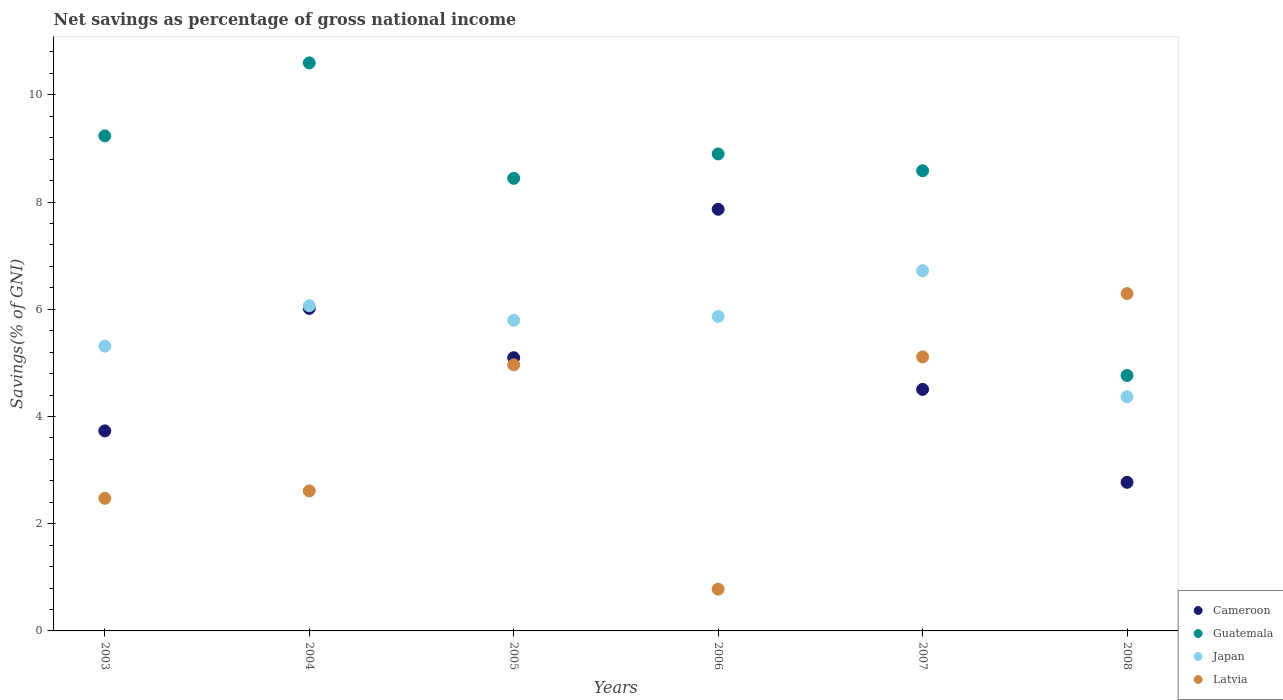What is the total savings in Japan in 2007?
Offer a terse response. 6.72. Across all years, what is the maximum total savings in Latvia?
Your answer should be very brief. 6.29. Across all years, what is the minimum total savings in Japan?
Make the answer very short. 4.37. In which year was the total savings in Latvia maximum?
Your answer should be compact. 2008. In which year was the total savings in Japan minimum?
Provide a succinct answer. 2008. What is the total total savings in Latvia in the graph?
Ensure brevity in your answer.  22.23. What is the difference between the total savings in Latvia in 2003 and that in 2006?
Provide a succinct answer. 1.69. What is the difference between the total savings in Cameroon in 2005 and the total savings in Japan in 2008?
Your response must be concise. 0.73. What is the average total savings in Latvia per year?
Your response must be concise. 3.71. In the year 2004, what is the difference between the total savings in Latvia and total savings in Cameroon?
Provide a succinct answer. -3.4. What is the ratio of the total savings in Japan in 2003 to that in 2008?
Your answer should be compact. 1.22. Is the total savings in Guatemala in 2003 less than that in 2007?
Give a very brief answer. No. Is the difference between the total savings in Latvia in 2003 and 2008 greater than the difference between the total savings in Cameroon in 2003 and 2008?
Offer a very short reply. No. What is the difference between the highest and the second highest total savings in Latvia?
Your answer should be compact. 1.18. What is the difference between the highest and the lowest total savings in Cameroon?
Give a very brief answer. 5.09. In how many years, is the total savings in Latvia greater than the average total savings in Latvia taken over all years?
Provide a succinct answer. 3. Is the sum of the total savings in Latvia in 2007 and 2008 greater than the maximum total savings in Japan across all years?
Your answer should be very brief. Yes. Is it the case that in every year, the sum of the total savings in Cameroon and total savings in Latvia  is greater than the sum of total savings in Guatemala and total savings in Japan?
Your answer should be very brief. No. Is it the case that in every year, the sum of the total savings in Guatemala and total savings in Cameroon  is greater than the total savings in Japan?
Your answer should be compact. Yes. Does the total savings in Japan monotonically increase over the years?
Give a very brief answer. No. Is the total savings in Latvia strictly greater than the total savings in Japan over the years?
Make the answer very short. No. Is the total savings in Guatemala strictly less than the total savings in Japan over the years?
Your answer should be very brief. No. Are the values on the major ticks of Y-axis written in scientific E-notation?
Offer a terse response. No. Does the graph contain any zero values?
Offer a terse response. No. Where does the legend appear in the graph?
Keep it short and to the point. Bottom right. What is the title of the graph?
Your answer should be very brief. Net savings as percentage of gross national income. Does "Togo" appear as one of the legend labels in the graph?
Your response must be concise. No. What is the label or title of the Y-axis?
Provide a short and direct response. Savings(% of GNI). What is the Savings(% of GNI) of Cameroon in 2003?
Provide a short and direct response. 3.73. What is the Savings(% of GNI) of Guatemala in 2003?
Provide a succinct answer. 9.24. What is the Savings(% of GNI) of Japan in 2003?
Offer a terse response. 5.31. What is the Savings(% of GNI) in Latvia in 2003?
Provide a short and direct response. 2.47. What is the Savings(% of GNI) of Cameroon in 2004?
Your answer should be very brief. 6.02. What is the Savings(% of GNI) of Guatemala in 2004?
Provide a succinct answer. 10.6. What is the Savings(% of GNI) in Japan in 2004?
Your answer should be very brief. 6.07. What is the Savings(% of GNI) of Latvia in 2004?
Ensure brevity in your answer.  2.61. What is the Savings(% of GNI) of Cameroon in 2005?
Ensure brevity in your answer.  5.1. What is the Savings(% of GNI) of Guatemala in 2005?
Provide a succinct answer. 8.44. What is the Savings(% of GNI) of Japan in 2005?
Make the answer very short. 5.79. What is the Savings(% of GNI) of Latvia in 2005?
Give a very brief answer. 4.96. What is the Savings(% of GNI) in Cameroon in 2006?
Offer a very short reply. 7.87. What is the Savings(% of GNI) in Guatemala in 2006?
Provide a short and direct response. 8.9. What is the Savings(% of GNI) of Japan in 2006?
Make the answer very short. 5.86. What is the Savings(% of GNI) in Latvia in 2006?
Provide a short and direct response. 0.78. What is the Savings(% of GNI) in Cameroon in 2007?
Offer a terse response. 4.51. What is the Savings(% of GNI) in Guatemala in 2007?
Give a very brief answer. 8.58. What is the Savings(% of GNI) in Japan in 2007?
Your answer should be compact. 6.72. What is the Savings(% of GNI) in Latvia in 2007?
Your answer should be very brief. 5.11. What is the Savings(% of GNI) in Cameroon in 2008?
Offer a terse response. 2.77. What is the Savings(% of GNI) in Guatemala in 2008?
Provide a short and direct response. 4.76. What is the Savings(% of GNI) in Japan in 2008?
Your answer should be compact. 4.37. What is the Savings(% of GNI) of Latvia in 2008?
Keep it short and to the point. 6.29. Across all years, what is the maximum Savings(% of GNI) of Cameroon?
Ensure brevity in your answer.  7.87. Across all years, what is the maximum Savings(% of GNI) of Guatemala?
Your answer should be compact. 10.6. Across all years, what is the maximum Savings(% of GNI) in Japan?
Make the answer very short. 6.72. Across all years, what is the maximum Savings(% of GNI) of Latvia?
Offer a very short reply. 6.29. Across all years, what is the minimum Savings(% of GNI) of Cameroon?
Provide a succinct answer. 2.77. Across all years, what is the minimum Savings(% of GNI) of Guatemala?
Keep it short and to the point. 4.76. Across all years, what is the minimum Savings(% of GNI) of Japan?
Offer a very short reply. 4.37. Across all years, what is the minimum Savings(% of GNI) of Latvia?
Your answer should be compact. 0.78. What is the total Savings(% of GNI) in Cameroon in the graph?
Provide a succinct answer. 29.99. What is the total Savings(% of GNI) of Guatemala in the graph?
Make the answer very short. 50.52. What is the total Savings(% of GNI) in Japan in the graph?
Provide a short and direct response. 34.12. What is the total Savings(% of GNI) in Latvia in the graph?
Your answer should be very brief. 22.23. What is the difference between the Savings(% of GNI) of Cameroon in 2003 and that in 2004?
Keep it short and to the point. -2.28. What is the difference between the Savings(% of GNI) in Guatemala in 2003 and that in 2004?
Keep it short and to the point. -1.36. What is the difference between the Savings(% of GNI) in Japan in 2003 and that in 2004?
Provide a short and direct response. -0.75. What is the difference between the Savings(% of GNI) of Latvia in 2003 and that in 2004?
Ensure brevity in your answer.  -0.14. What is the difference between the Savings(% of GNI) in Cameroon in 2003 and that in 2005?
Offer a terse response. -1.36. What is the difference between the Savings(% of GNI) in Guatemala in 2003 and that in 2005?
Your response must be concise. 0.79. What is the difference between the Savings(% of GNI) in Japan in 2003 and that in 2005?
Your answer should be very brief. -0.48. What is the difference between the Savings(% of GNI) of Latvia in 2003 and that in 2005?
Provide a succinct answer. -2.49. What is the difference between the Savings(% of GNI) in Cameroon in 2003 and that in 2006?
Offer a very short reply. -4.13. What is the difference between the Savings(% of GNI) in Guatemala in 2003 and that in 2006?
Make the answer very short. 0.34. What is the difference between the Savings(% of GNI) in Japan in 2003 and that in 2006?
Make the answer very short. -0.55. What is the difference between the Savings(% of GNI) of Latvia in 2003 and that in 2006?
Offer a terse response. 1.7. What is the difference between the Savings(% of GNI) of Cameroon in 2003 and that in 2007?
Provide a short and direct response. -0.77. What is the difference between the Savings(% of GNI) in Guatemala in 2003 and that in 2007?
Provide a short and direct response. 0.65. What is the difference between the Savings(% of GNI) in Japan in 2003 and that in 2007?
Your response must be concise. -1.41. What is the difference between the Savings(% of GNI) in Latvia in 2003 and that in 2007?
Make the answer very short. -2.64. What is the difference between the Savings(% of GNI) in Cameroon in 2003 and that in 2008?
Your answer should be compact. 0.96. What is the difference between the Savings(% of GNI) in Guatemala in 2003 and that in 2008?
Give a very brief answer. 4.47. What is the difference between the Savings(% of GNI) of Japan in 2003 and that in 2008?
Your answer should be very brief. 0.94. What is the difference between the Savings(% of GNI) of Latvia in 2003 and that in 2008?
Offer a terse response. -3.82. What is the difference between the Savings(% of GNI) of Cameroon in 2004 and that in 2005?
Offer a very short reply. 0.92. What is the difference between the Savings(% of GNI) in Guatemala in 2004 and that in 2005?
Your answer should be very brief. 2.15. What is the difference between the Savings(% of GNI) in Japan in 2004 and that in 2005?
Provide a short and direct response. 0.27. What is the difference between the Savings(% of GNI) of Latvia in 2004 and that in 2005?
Give a very brief answer. -2.35. What is the difference between the Savings(% of GNI) in Cameroon in 2004 and that in 2006?
Give a very brief answer. -1.85. What is the difference between the Savings(% of GNI) of Guatemala in 2004 and that in 2006?
Give a very brief answer. 1.7. What is the difference between the Savings(% of GNI) in Japan in 2004 and that in 2006?
Ensure brevity in your answer.  0.2. What is the difference between the Savings(% of GNI) of Latvia in 2004 and that in 2006?
Give a very brief answer. 1.83. What is the difference between the Savings(% of GNI) of Cameroon in 2004 and that in 2007?
Your answer should be very brief. 1.51. What is the difference between the Savings(% of GNI) of Guatemala in 2004 and that in 2007?
Your answer should be compact. 2.01. What is the difference between the Savings(% of GNI) of Japan in 2004 and that in 2007?
Offer a very short reply. -0.65. What is the difference between the Savings(% of GNI) in Latvia in 2004 and that in 2007?
Give a very brief answer. -2.5. What is the difference between the Savings(% of GNI) of Cameroon in 2004 and that in 2008?
Your answer should be compact. 3.24. What is the difference between the Savings(% of GNI) in Guatemala in 2004 and that in 2008?
Give a very brief answer. 5.83. What is the difference between the Savings(% of GNI) in Japan in 2004 and that in 2008?
Ensure brevity in your answer.  1.7. What is the difference between the Savings(% of GNI) in Latvia in 2004 and that in 2008?
Ensure brevity in your answer.  -3.68. What is the difference between the Savings(% of GNI) of Cameroon in 2005 and that in 2006?
Offer a very short reply. -2.77. What is the difference between the Savings(% of GNI) of Guatemala in 2005 and that in 2006?
Provide a succinct answer. -0.46. What is the difference between the Savings(% of GNI) in Japan in 2005 and that in 2006?
Your answer should be very brief. -0.07. What is the difference between the Savings(% of GNI) of Latvia in 2005 and that in 2006?
Your response must be concise. 4.19. What is the difference between the Savings(% of GNI) in Cameroon in 2005 and that in 2007?
Your response must be concise. 0.59. What is the difference between the Savings(% of GNI) of Guatemala in 2005 and that in 2007?
Offer a terse response. -0.14. What is the difference between the Savings(% of GNI) in Japan in 2005 and that in 2007?
Your answer should be compact. -0.93. What is the difference between the Savings(% of GNI) in Latvia in 2005 and that in 2007?
Provide a short and direct response. -0.15. What is the difference between the Savings(% of GNI) of Cameroon in 2005 and that in 2008?
Provide a short and direct response. 2.32. What is the difference between the Savings(% of GNI) in Guatemala in 2005 and that in 2008?
Make the answer very short. 3.68. What is the difference between the Savings(% of GNI) of Japan in 2005 and that in 2008?
Offer a very short reply. 1.42. What is the difference between the Savings(% of GNI) in Latvia in 2005 and that in 2008?
Provide a short and direct response. -1.33. What is the difference between the Savings(% of GNI) in Cameroon in 2006 and that in 2007?
Provide a succinct answer. 3.36. What is the difference between the Savings(% of GNI) of Guatemala in 2006 and that in 2007?
Provide a succinct answer. 0.31. What is the difference between the Savings(% of GNI) of Japan in 2006 and that in 2007?
Make the answer very short. -0.85. What is the difference between the Savings(% of GNI) of Latvia in 2006 and that in 2007?
Your response must be concise. -4.33. What is the difference between the Savings(% of GNI) in Cameroon in 2006 and that in 2008?
Your answer should be very brief. 5.09. What is the difference between the Savings(% of GNI) in Guatemala in 2006 and that in 2008?
Offer a terse response. 4.13. What is the difference between the Savings(% of GNI) of Japan in 2006 and that in 2008?
Give a very brief answer. 1.5. What is the difference between the Savings(% of GNI) of Latvia in 2006 and that in 2008?
Your response must be concise. -5.52. What is the difference between the Savings(% of GNI) of Cameroon in 2007 and that in 2008?
Your response must be concise. 1.73. What is the difference between the Savings(% of GNI) in Guatemala in 2007 and that in 2008?
Your answer should be compact. 3.82. What is the difference between the Savings(% of GNI) in Japan in 2007 and that in 2008?
Offer a very short reply. 2.35. What is the difference between the Savings(% of GNI) in Latvia in 2007 and that in 2008?
Provide a short and direct response. -1.18. What is the difference between the Savings(% of GNI) in Cameroon in 2003 and the Savings(% of GNI) in Guatemala in 2004?
Give a very brief answer. -6.86. What is the difference between the Savings(% of GNI) in Cameroon in 2003 and the Savings(% of GNI) in Japan in 2004?
Give a very brief answer. -2.33. What is the difference between the Savings(% of GNI) in Cameroon in 2003 and the Savings(% of GNI) in Latvia in 2004?
Give a very brief answer. 1.12. What is the difference between the Savings(% of GNI) in Guatemala in 2003 and the Savings(% of GNI) in Japan in 2004?
Ensure brevity in your answer.  3.17. What is the difference between the Savings(% of GNI) of Guatemala in 2003 and the Savings(% of GNI) of Latvia in 2004?
Ensure brevity in your answer.  6.62. What is the difference between the Savings(% of GNI) in Japan in 2003 and the Savings(% of GNI) in Latvia in 2004?
Provide a short and direct response. 2.7. What is the difference between the Savings(% of GNI) in Cameroon in 2003 and the Savings(% of GNI) in Guatemala in 2005?
Give a very brief answer. -4.71. What is the difference between the Savings(% of GNI) in Cameroon in 2003 and the Savings(% of GNI) in Japan in 2005?
Offer a very short reply. -2.06. What is the difference between the Savings(% of GNI) in Cameroon in 2003 and the Savings(% of GNI) in Latvia in 2005?
Your answer should be compact. -1.23. What is the difference between the Savings(% of GNI) of Guatemala in 2003 and the Savings(% of GNI) of Japan in 2005?
Ensure brevity in your answer.  3.44. What is the difference between the Savings(% of GNI) in Guatemala in 2003 and the Savings(% of GNI) in Latvia in 2005?
Keep it short and to the point. 4.27. What is the difference between the Savings(% of GNI) in Japan in 2003 and the Savings(% of GNI) in Latvia in 2005?
Offer a very short reply. 0.35. What is the difference between the Savings(% of GNI) of Cameroon in 2003 and the Savings(% of GNI) of Guatemala in 2006?
Offer a terse response. -5.17. What is the difference between the Savings(% of GNI) of Cameroon in 2003 and the Savings(% of GNI) of Japan in 2006?
Ensure brevity in your answer.  -2.13. What is the difference between the Savings(% of GNI) of Cameroon in 2003 and the Savings(% of GNI) of Latvia in 2006?
Provide a short and direct response. 2.95. What is the difference between the Savings(% of GNI) in Guatemala in 2003 and the Savings(% of GNI) in Japan in 2006?
Make the answer very short. 3.37. What is the difference between the Savings(% of GNI) of Guatemala in 2003 and the Savings(% of GNI) of Latvia in 2006?
Provide a succinct answer. 8.46. What is the difference between the Savings(% of GNI) in Japan in 2003 and the Savings(% of GNI) in Latvia in 2006?
Offer a terse response. 4.53. What is the difference between the Savings(% of GNI) of Cameroon in 2003 and the Savings(% of GNI) of Guatemala in 2007?
Your answer should be compact. -4.85. What is the difference between the Savings(% of GNI) in Cameroon in 2003 and the Savings(% of GNI) in Japan in 2007?
Make the answer very short. -2.99. What is the difference between the Savings(% of GNI) in Cameroon in 2003 and the Savings(% of GNI) in Latvia in 2007?
Ensure brevity in your answer.  -1.38. What is the difference between the Savings(% of GNI) in Guatemala in 2003 and the Savings(% of GNI) in Japan in 2007?
Your answer should be compact. 2.52. What is the difference between the Savings(% of GNI) of Guatemala in 2003 and the Savings(% of GNI) of Latvia in 2007?
Ensure brevity in your answer.  4.12. What is the difference between the Savings(% of GNI) of Japan in 2003 and the Savings(% of GNI) of Latvia in 2007?
Ensure brevity in your answer.  0.2. What is the difference between the Savings(% of GNI) of Cameroon in 2003 and the Savings(% of GNI) of Guatemala in 2008?
Your response must be concise. -1.03. What is the difference between the Savings(% of GNI) of Cameroon in 2003 and the Savings(% of GNI) of Japan in 2008?
Give a very brief answer. -0.64. What is the difference between the Savings(% of GNI) of Cameroon in 2003 and the Savings(% of GNI) of Latvia in 2008?
Your answer should be very brief. -2.56. What is the difference between the Savings(% of GNI) of Guatemala in 2003 and the Savings(% of GNI) of Japan in 2008?
Your answer should be compact. 4.87. What is the difference between the Savings(% of GNI) in Guatemala in 2003 and the Savings(% of GNI) in Latvia in 2008?
Your response must be concise. 2.94. What is the difference between the Savings(% of GNI) of Japan in 2003 and the Savings(% of GNI) of Latvia in 2008?
Keep it short and to the point. -0.98. What is the difference between the Savings(% of GNI) in Cameroon in 2004 and the Savings(% of GNI) in Guatemala in 2005?
Offer a very short reply. -2.43. What is the difference between the Savings(% of GNI) in Cameroon in 2004 and the Savings(% of GNI) in Japan in 2005?
Offer a very short reply. 0.22. What is the difference between the Savings(% of GNI) of Cameroon in 2004 and the Savings(% of GNI) of Latvia in 2005?
Your answer should be compact. 1.05. What is the difference between the Savings(% of GNI) of Guatemala in 2004 and the Savings(% of GNI) of Japan in 2005?
Offer a terse response. 4.8. What is the difference between the Savings(% of GNI) of Guatemala in 2004 and the Savings(% of GNI) of Latvia in 2005?
Ensure brevity in your answer.  5.63. What is the difference between the Savings(% of GNI) in Japan in 2004 and the Savings(% of GNI) in Latvia in 2005?
Provide a short and direct response. 1.1. What is the difference between the Savings(% of GNI) in Cameroon in 2004 and the Savings(% of GNI) in Guatemala in 2006?
Your response must be concise. -2.88. What is the difference between the Savings(% of GNI) in Cameroon in 2004 and the Savings(% of GNI) in Japan in 2006?
Keep it short and to the point. 0.15. What is the difference between the Savings(% of GNI) of Cameroon in 2004 and the Savings(% of GNI) of Latvia in 2006?
Offer a very short reply. 5.24. What is the difference between the Savings(% of GNI) in Guatemala in 2004 and the Savings(% of GNI) in Japan in 2006?
Your answer should be very brief. 4.73. What is the difference between the Savings(% of GNI) of Guatemala in 2004 and the Savings(% of GNI) of Latvia in 2006?
Provide a short and direct response. 9.82. What is the difference between the Savings(% of GNI) of Japan in 2004 and the Savings(% of GNI) of Latvia in 2006?
Make the answer very short. 5.29. What is the difference between the Savings(% of GNI) of Cameroon in 2004 and the Savings(% of GNI) of Guatemala in 2007?
Your answer should be compact. -2.57. What is the difference between the Savings(% of GNI) in Cameroon in 2004 and the Savings(% of GNI) in Japan in 2007?
Give a very brief answer. -0.7. What is the difference between the Savings(% of GNI) of Cameroon in 2004 and the Savings(% of GNI) of Latvia in 2007?
Make the answer very short. 0.9. What is the difference between the Savings(% of GNI) of Guatemala in 2004 and the Savings(% of GNI) of Japan in 2007?
Your answer should be very brief. 3.88. What is the difference between the Savings(% of GNI) of Guatemala in 2004 and the Savings(% of GNI) of Latvia in 2007?
Ensure brevity in your answer.  5.48. What is the difference between the Savings(% of GNI) in Japan in 2004 and the Savings(% of GNI) in Latvia in 2007?
Offer a terse response. 0.95. What is the difference between the Savings(% of GNI) of Cameroon in 2004 and the Savings(% of GNI) of Guatemala in 2008?
Your answer should be compact. 1.25. What is the difference between the Savings(% of GNI) of Cameroon in 2004 and the Savings(% of GNI) of Japan in 2008?
Keep it short and to the point. 1.65. What is the difference between the Savings(% of GNI) in Cameroon in 2004 and the Savings(% of GNI) in Latvia in 2008?
Provide a succinct answer. -0.28. What is the difference between the Savings(% of GNI) in Guatemala in 2004 and the Savings(% of GNI) in Japan in 2008?
Provide a succinct answer. 6.23. What is the difference between the Savings(% of GNI) of Guatemala in 2004 and the Savings(% of GNI) of Latvia in 2008?
Your answer should be very brief. 4.3. What is the difference between the Savings(% of GNI) in Japan in 2004 and the Savings(% of GNI) in Latvia in 2008?
Make the answer very short. -0.23. What is the difference between the Savings(% of GNI) in Cameroon in 2005 and the Savings(% of GNI) in Guatemala in 2006?
Provide a succinct answer. -3.8. What is the difference between the Savings(% of GNI) of Cameroon in 2005 and the Savings(% of GNI) of Japan in 2006?
Keep it short and to the point. -0.77. What is the difference between the Savings(% of GNI) of Cameroon in 2005 and the Savings(% of GNI) of Latvia in 2006?
Offer a terse response. 4.32. What is the difference between the Savings(% of GNI) in Guatemala in 2005 and the Savings(% of GNI) in Japan in 2006?
Provide a succinct answer. 2.58. What is the difference between the Savings(% of GNI) of Guatemala in 2005 and the Savings(% of GNI) of Latvia in 2006?
Provide a short and direct response. 7.66. What is the difference between the Savings(% of GNI) in Japan in 2005 and the Savings(% of GNI) in Latvia in 2006?
Your answer should be compact. 5.01. What is the difference between the Savings(% of GNI) in Cameroon in 2005 and the Savings(% of GNI) in Guatemala in 2007?
Provide a succinct answer. -3.49. What is the difference between the Savings(% of GNI) of Cameroon in 2005 and the Savings(% of GNI) of Japan in 2007?
Offer a terse response. -1.62. What is the difference between the Savings(% of GNI) in Cameroon in 2005 and the Savings(% of GNI) in Latvia in 2007?
Provide a succinct answer. -0.02. What is the difference between the Savings(% of GNI) of Guatemala in 2005 and the Savings(% of GNI) of Japan in 2007?
Offer a terse response. 1.72. What is the difference between the Savings(% of GNI) in Guatemala in 2005 and the Savings(% of GNI) in Latvia in 2007?
Provide a succinct answer. 3.33. What is the difference between the Savings(% of GNI) of Japan in 2005 and the Savings(% of GNI) of Latvia in 2007?
Offer a very short reply. 0.68. What is the difference between the Savings(% of GNI) in Cameroon in 2005 and the Savings(% of GNI) in Guatemala in 2008?
Offer a terse response. 0.33. What is the difference between the Savings(% of GNI) of Cameroon in 2005 and the Savings(% of GNI) of Japan in 2008?
Offer a very short reply. 0.73. What is the difference between the Savings(% of GNI) of Cameroon in 2005 and the Savings(% of GNI) of Latvia in 2008?
Ensure brevity in your answer.  -1.2. What is the difference between the Savings(% of GNI) in Guatemala in 2005 and the Savings(% of GNI) in Japan in 2008?
Provide a short and direct response. 4.07. What is the difference between the Savings(% of GNI) of Guatemala in 2005 and the Savings(% of GNI) of Latvia in 2008?
Your answer should be compact. 2.15. What is the difference between the Savings(% of GNI) of Japan in 2005 and the Savings(% of GNI) of Latvia in 2008?
Your answer should be very brief. -0.5. What is the difference between the Savings(% of GNI) of Cameroon in 2006 and the Savings(% of GNI) of Guatemala in 2007?
Keep it short and to the point. -0.72. What is the difference between the Savings(% of GNI) of Cameroon in 2006 and the Savings(% of GNI) of Japan in 2007?
Provide a succinct answer. 1.15. What is the difference between the Savings(% of GNI) in Cameroon in 2006 and the Savings(% of GNI) in Latvia in 2007?
Offer a terse response. 2.75. What is the difference between the Savings(% of GNI) of Guatemala in 2006 and the Savings(% of GNI) of Japan in 2007?
Provide a short and direct response. 2.18. What is the difference between the Savings(% of GNI) in Guatemala in 2006 and the Savings(% of GNI) in Latvia in 2007?
Your response must be concise. 3.79. What is the difference between the Savings(% of GNI) in Japan in 2006 and the Savings(% of GNI) in Latvia in 2007?
Provide a succinct answer. 0.75. What is the difference between the Savings(% of GNI) of Cameroon in 2006 and the Savings(% of GNI) of Guatemala in 2008?
Offer a terse response. 3.1. What is the difference between the Savings(% of GNI) in Cameroon in 2006 and the Savings(% of GNI) in Japan in 2008?
Give a very brief answer. 3.5. What is the difference between the Savings(% of GNI) in Cameroon in 2006 and the Savings(% of GNI) in Latvia in 2008?
Your answer should be very brief. 1.57. What is the difference between the Savings(% of GNI) of Guatemala in 2006 and the Savings(% of GNI) of Japan in 2008?
Give a very brief answer. 4.53. What is the difference between the Savings(% of GNI) in Guatemala in 2006 and the Savings(% of GNI) in Latvia in 2008?
Provide a short and direct response. 2.6. What is the difference between the Savings(% of GNI) of Japan in 2006 and the Savings(% of GNI) of Latvia in 2008?
Make the answer very short. -0.43. What is the difference between the Savings(% of GNI) of Cameroon in 2007 and the Savings(% of GNI) of Guatemala in 2008?
Give a very brief answer. -0.26. What is the difference between the Savings(% of GNI) of Cameroon in 2007 and the Savings(% of GNI) of Japan in 2008?
Keep it short and to the point. 0.14. What is the difference between the Savings(% of GNI) of Cameroon in 2007 and the Savings(% of GNI) of Latvia in 2008?
Your response must be concise. -1.79. What is the difference between the Savings(% of GNI) in Guatemala in 2007 and the Savings(% of GNI) in Japan in 2008?
Offer a very short reply. 4.22. What is the difference between the Savings(% of GNI) in Guatemala in 2007 and the Savings(% of GNI) in Latvia in 2008?
Keep it short and to the point. 2.29. What is the difference between the Savings(% of GNI) of Japan in 2007 and the Savings(% of GNI) of Latvia in 2008?
Make the answer very short. 0.43. What is the average Savings(% of GNI) of Cameroon per year?
Your response must be concise. 5. What is the average Savings(% of GNI) of Guatemala per year?
Offer a very short reply. 8.42. What is the average Savings(% of GNI) of Japan per year?
Provide a short and direct response. 5.69. What is the average Savings(% of GNI) in Latvia per year?
Ensure brevity in your answer.  3.71. In the year 2003, what is the difference between the Savings(% of GNI) in Cameroon and Savings(% of GNI) in Guatemala?
Your answer should be compact. -5.5. In the year 2003, what is the difference between the Savings(% of GNI) in Cameroon and Savings(% of GNI) in Japan?
Make the answer very short. -1.58. In the year 2003, what is the difference between the Savings(% of GNI) of Cameroon and Savings(% of GNI) of Latvia?
Provide a succinct answer. 1.26. In the year 2003, what is the difference between the Savings(% of GNI) of Guatemala and Savings(% of GNI) of Japan?
Make the answer very short. 3.92. In the year 2003, what is the difference between the Savings(% of GNI) in Guatemala and Savings(% of GNI) in Latvia?
Your answer should be compact. 6.76. In the year 2003, what is the difference between the Savings(% of GNI) of Japan and Savings(% of GNI) of Latvia?
Give a very brief answer. 2.84. In the year 2004, what is the difference between the Savings(% of GNI) in Cameroon and Savings(% of GNI) in Guatemala?
Your response must be concise. -4.58. In the year 2004, what is the difference between the Savings(% of GNI) in Cameroon and Savings(% of GNI) in Japan?
Provide a short and direct response. -0.05. In the year 2004, what is the difference between the Savings(% of GNI) of Cameroon and Savings(% of GNI) of Latvia?
Keep it short and to the point. 3.4. In the year 2004, what is the difference between the Savings(% of GNI) in Guatemala and Savings(% of GNI) in Japan?
Provide a succinct answer. 4.53. In the year 2004, what is the difference between the Savings(% of GNI) in Guatemala and Savings(% of GNI) in Latvia?
Your response must be concise. 7.98. In the year 2004, what is the difference between the Savings(% of GNI) of Japan and Savings(% of GNI) of Latvia?
Offer a terse response. 3.45. In the year 2005, what is the difference between the Savings(% of GNI) in Cameroon and Savings(% of GNI) in Guatemala?
Provide a short and direct response. -3.35. In the year 2005, what is the difference between the Savings(% of GNI) of Cameroon and Savings(% of GNI) of Japan?
Ensure brevity in your answer.  -0.7. In the year 2005, what is the difference between the Savings(% of GNI) of Cameroon and Savings(% of GNI) of Latvia?
Your response must be concise. 0.13. In the year 2005, what is the difference between the Savings(% of GNI) of Guatemala and Savings(% of GNI) of Japan?
Ensure brevity in your answer.  2.65. In the year 2005, what is the difference between the Savings(% of GNI) of Guatemala and Savings(% of GNI) of Latvia?
Provide a short and direct response. 3.48. In the year 2005, what is the difference between the Savings(% of GNI) in Japan and Savings(% of GNI) in Latvia?
Make the answer very short. 0.83. In the year 2006, what is the difference between the Savings(% of GNI) of Cameroon and Savings(% of GNI) of Guatemala?
Your response must be concise. -1.03. In the year 2006, what is the difference between the Savings(% of GNI) in Cameroon and Savings(% of GNI) in Japan?
Your answer should be very brief. 2. In the year 2006, what is the difference between the Savings(% of GNI) of Cameroon and Savings(% of GNI) of Latvia?
Provide a short and direct response. 7.09. In the year 2006, what is the difference between the Savings(% of GNI) in Guatemala and Savings(% of GNI) in Japan?
Your answer should be very brief. 3.03. In the year 2006, what is the difference between the Savings(% of GNI) of Guatemala and Savings(% of GNI) of Latvia?
Ensure brevity in your answer.  8.12. In the year 2006, what is the difference between the Savings(% of GNI) in Japan and Savings(% of GNI) in Latvia?
Your answer should be very brief. 5.09. In the year 2007, what is the difference between the Savings(% of GNI) in Cameroon and Savings(% of GNI) in Guatemala?
Offer a terse response. -4.08. In the year 2007, what is the difference between the Savings(% of GNI) of Cameroon and Savings(% of GNI) of Japan?
Your response must be concise. -2.21. In the year 2007, what is the difference between the Savings(% of GNI) of Cameroon and Savings(% of GNI) of Latvia?
Provide a succinct answer. -0.61. In the year 2007, what is the difference between the Savings(% of GNI) in Guatemala and Savings(% of GNI) in Japan?
Your answer should be very brief. 1.86. In the year 2007, what is the difference between the Savings(% of GNI) in Guatemala and Savings(% of GNI) in Latvia?
Your response must be concise. 3.47. In the year 2007, what is the difference between the Savings(% of GNI) in Japan and Savings(% of GNI) in Latvia?
Keep it short and to the point. 1.61. In the year 2008, what is the difference between the Savings(% of GNI) of Cameroon and Savings(% of GNI) of Guatemala?
Keep it short and to the point. -1.99. In the year 2008, what is the difference between the Savings(% of GNI) of Cameroon and Savings(% of GNI) of Japan?
Your response must be concise. -1.6. In the year 2008, what is the difference between the Savings(% of GNI) of Cameroon and Savings(% of GNI) of Latvia?
Keep it short and to the point. -3.52. In the year 2008, what is the difference between the Savings(% of GNI) of Guatemala and Savings(% of GNI) of Japan?
Provide a succinct answer. 0.4. In the year 2008, what is the difference between the Savings(% of GNI) of Guatemala and Savings(% of GNI) of Latvia?
Ensure brevity in your answer.  -1.53. In the year 2008, what is the difference between the Savings(% of GNI) of Japan and Savings(% of GNI) of Latvia?
Your answer should be very brief. -1.93. What is the ratio of the Savings(% of GNI) in Cameroon in 2003 to that in 2004?
Your answer should be compact. 0.62. What is the ratio of the Savings(% of GNI) in Guatemala in 2003 to that in 2004?
Your answer should be very brief. 0.87. What is the ratio of the Savings(% of GNI) of Japan in 2003 to that in 2004?
Give a very brief answer. 0.88. What is the ratio of the Savings(% of GNI) of Latvia in 2003 to that in 2004?
Ensure brevity in your answer.  0.95. What is the ratio of the Savings(% of GNI) in Cameroon in 2003 to that in 2005?
Provide a succinct answer. 0.73. What is the ratio of the Savings(% of GNI) of Guatemala in 2003 to that in 2005?
Keep it short and to the point. 1.09. What is the ratio of the Savings(% of GNI) of Japan in 2003 to that in 2005?
Your answer should be very brief. 0.92. What is the ratio of the Savings(% of GNI) of Latvia in 2003 to that in 2005?
Provide a short and direct response. 0.5. What is the ratio of the Savings(% of GNI) of Cameroon in 2003 to that in 2006?
Give a very brief answer. 0.47. What is the ratio of the Savings(% of GNI) in Guatemala in 2003 to that in 2006?
Provide a succinct answer. 1.04. What is the ratio of the Savings(% of GNI) in Japan in 2003 to that in 2006?
Give a very brief answer. 0.91. What is the ratio of the Savings(% of GNI) in Latvia in 2003 to that in 2006?
Offer a terse response. 3.18. What is the ratio of the Savings(% of GNI) in Cameroon in 2003 to that in 2007?
Provide a short and direct response. 0.83. What is the ratio of the Savings(% of GNI) of Guatemala in 2003 to that in 2007?
Ensure brevity in your answer.  1.08. What is the ratio of the Savings(% of GNI) of Japan in 2003 to that in 2007?
Your answer should be very brief. 0.79. What is the ratio of the Savings(% of GNI) of Latvia in 2003 to that in 2007?
Your answer should be compact. 0.48. What is the ratio of the Savings(% of GNI) in Cameroon in 2003 to that in 2008?
Provide a short and direct response. 1.35. What is the ratio of the Savings(% of GNI) in Guatemala in 2003 to that in 2008?
Keep it short and to the point. 1.94. What is the ratio of the Savings(% of GNI) of Japan in 2003 to that in 2008?
Offer a very short reply. 1.22. What is the ratio of the Savings(% of GNI) in Latvia in 2003 to that in 2008?
Keep it short and to the point. 0.39. What is the ratio of the Savings(% of GNI) in Cameroon in 2004 to that in 2005?
Your answer should be very brief. 1.18. What is the ratio of the Savings(% of GNI) of Guatemala in 2004 to that in 2005?
Your response must be concise. 1.26. What is the ratio of the Savings(% of GNI) in Japan in 2004 to that in 2005?
Keep it short and to the point. 1.05. What is the ratio of the Savings(% of GNI) of Latvia in 2004 to that in 2005?
Offer a very short reply. 0.53. What is the ratio of the Savings(% of GNI) of Cameroon in 2004 to that in 2006?
Give a very brief answer. 0.76. What is the ratio of the Savings(% of GNI) of Guatemala in 2004 to that in 2006?
Keep it short and to the point. 1.19. What is the ratio of the Savings(% of GNI) in Japan in 2004 to that in 2006?
Give a very brief answer. 1.03. What is the ratio of the Savings(% of GNI) of Latvia in 2004 to that in 2006?
Give a very brief answer. 3.35. What is the ratio of the Savings(% of GNI) in Cameroon in 2004 to that in 2007?
Keep it short and to the point. 1.33. What is the ratio of the Savings(% of GNI) of Guatemala in 2004 to that in 2007?
Give a very brief answer. 1.23. What is the ratio of the Savings(% of GNI) of Japan in 2004 to that in 2007?
Offer a very short reply. 0.9. What is the ratio of the Savings(% of GNI) in Latvia in 2004 to that in 2007?
Keep it short and to the point. 0.51. What is the ratio of the Savings(% of GNI) of Cameroon in 2004 to that in 2008?
Offer a very short reply. 2.17. What is the ratio of the Savings(% of GNI) of Guatemala in 2004 to that in 2008?
Provide a short and direct response. 2.22. What is the ratio of the Savings(% of GNI) of Japan in 2004 to that in 2008?
Keep it short and to the point. 1.39. What is the ratio of the Savings(% of GNI) of Latvia in 2004 to that in 2008?
Your answer should be compact. 0.41. What is the ratio of the Savings(% of GNI) in Cameroon in 2005 to that in 2006?
Provide a short and direct response. 0.65. What is the ratio of the Savings(% of GNI) of Guatemala in 2005 to that in 2006?
Your response must be concise. 0.95. What is the ratio of the Savings(% of GNI) of Japan in 2005 to that in 2006?
Offer a very short reply. 0.99. What is the ratio of the Savings(% of GNI) in Latvia in 2005 to that in 2006?
Your answer should be very brief. 6.38. What is the ratio of the Savings(% of GNI) in Cameroon in 2005 to that in 2007?
Offer a very short reply. 1.13. What is the ratio of the Savings(% of GNI) in Guatemala in 2005 to that in 2007?
Make the answer very short. 0.98. What is the ratio of the Savings(% of GNI) in Japan in 2005 to that in 2007?
Provide a succinct answer. 0.86. What is the ratio of the Savings(% of GNI) in Latvia in 2005 to that in 2007?
Provide a short and direct response. 0.97. What is the ratio of the Savings(% of GNI) of Cameroon in 2005 to that in 2008?
Offer a very short reply. 1.84. What is the ratio of the Savings(% of GNI) of Guatemala in 2005 to that in 2008?
Provide a succinct answer. 1.77. What is the ratio of the Savings(% of GNI) of Japan in 2005 to that in 2008?
Your response must be concise. 1.33. What is the ratio of the Savings(% of GNI) in Latvia in 2005 to that in 2008?
Ensure brevity in your answer.  0.79. What is the ratio of the Savings(% of GNI) in Cameroon in 2006 to that in 2007?
Provide a short and direct response. 1.75. What is the ratio of the Savings(% of GNI) in Guatemala in 2006 to that in 2007?
Give a very brief answer. 1.04. What is the ratio of the Savings(% of GNI) of Japan in 2006 to that in 2007?
Your response must be concise. 0.87. What is the ratio of the Savings(% of GNI) of Latvia in 2006 to that in 2007?
Offer a terse response. 0.15. What is the ratio of the Savings(% of GNI) of Cameroon in 2006 to that in 2008?
Ensure brevity in your answer.  2.84. What is the ratio of the Savings(% of GNI) in Guatemala in 2006 to that in 2008?
Give a very brief answer. 1.87. What is the ratio of the Savings(% of GNI) of Japan in 2006 to that in 2008?
Offer a very short reply. 1.34. What is the ratio of the Savings(% of GNI) in Latvia in 2006 to that in 2008?
Provide a succinct answer. 0.12. What is the ratio of the Savings(% of GNI) of Cameroon in 2007 to that in 2008?
Provide a short and direct response. 1.63. What is the ratio of the Savings(% of GNI) in Guatemala in 2007 to that in 2008?
Provide a succinct answer. 1.8. What is the ratio of the Savings(% of GNI) of Japan in 2007 to that in 2008?
Your response must be concise. 1.54. What is the ratio of the Savings(% of GNI) of Latvia in 2007 to that in 2008?
Give a very brief answer. 0.81. What is the difference between the highest and the second highest Savings(% of GNI) of Cameroon?
Give a very brief answer. 1.85. What is the difference between the highest and the second highest Savings(% of GNI) in Guatemala?
Your answer should be very brief. 1.36. What is the difference between the highest and the second highest Savings(% of GNI) of Japan?
Your response must be concise. 0.65. What is the difference between the highest and the second highest Savings(% of GNI) of Latvia?
Offer a terse response. 1.18. What is the difference between the highest and the lowest Savings(% of GNI) in Cameroon?
Your response must be concise. 5.09. What is the difference between the highest and the lowest Savings(% of GNI) of Guatemala?
Keep it short and to the point. 5.83. What is the difference between the highest and the lowest Savings(% of GNI) of Japan?
Offer a very short reply. 2.35. What is the difference between the highest and the lowest Savings(% of GNI) of Latvia?
Ensure brevity in your answer.  5.52. 